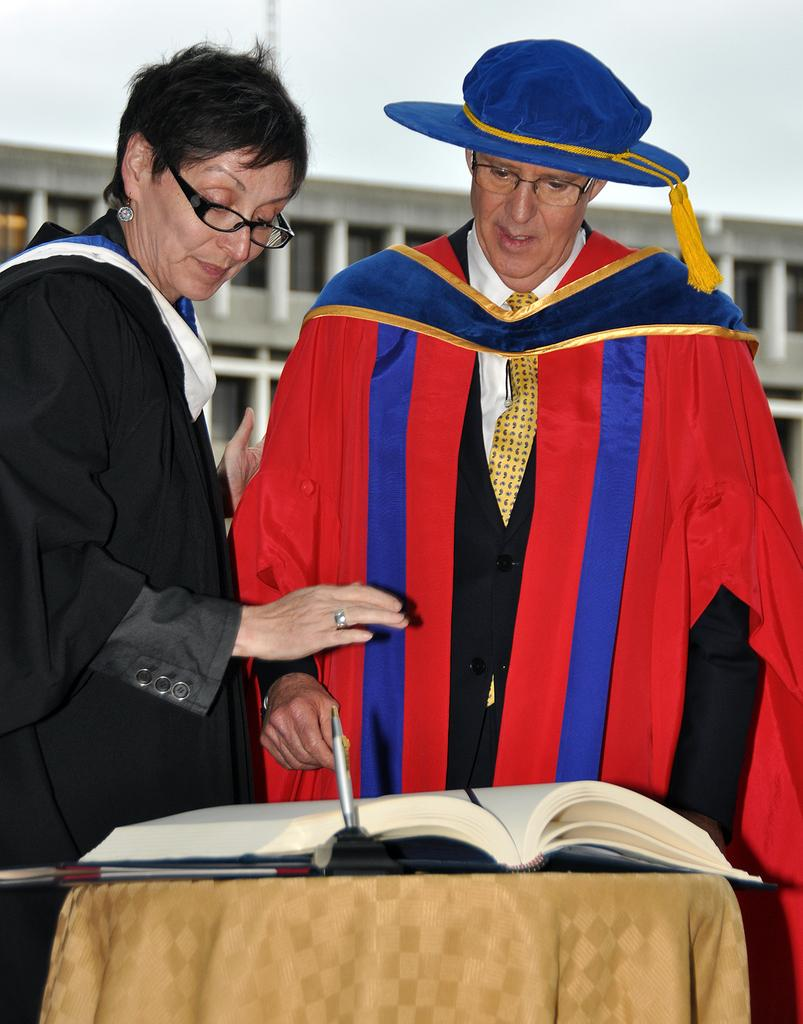Who is present in the image? There is a man and a woman in the image. What are the man and woman doing in the image? The man and woman are looking into a book on a table. What object is on the table besides the book? There is a pen on the table. What can be seen in the background of the image? There is a building visible in the background of the image. How many fingers does the account have in the image? There is no account present in the image, and therefore no fingers or number of fingers can be associated with it. 